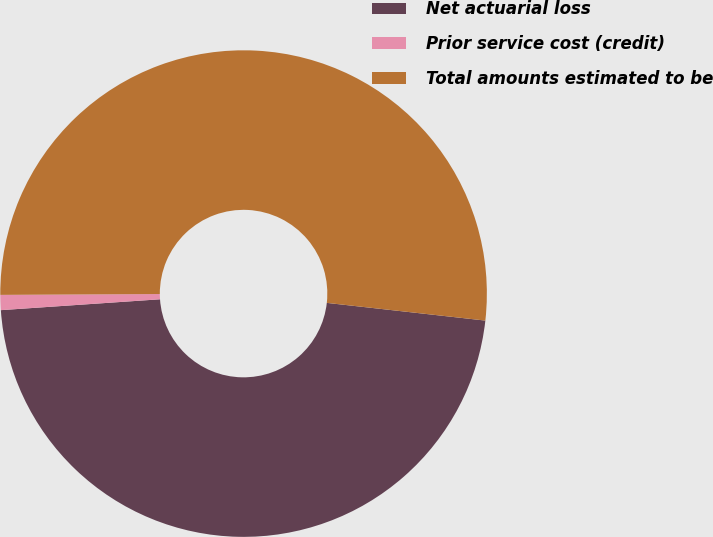Convert chart. <chart><loc_0><loc_0><loc_500><loc_500><pie_chart><fcel>Net actuarial loss<fcel>Prior service cost (credit)<fcel>Total amounts estimated to be<nl><fcel>47.15%<fcel>1.0%<fcel>51.86%<nl></chart> 